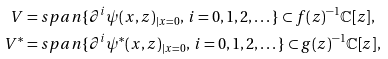Convert formula to latex. <formula><loc_0><loc_0><loc_500><loc_500>V & = s p a n \{ \partial ^ { i } \psi ( x , z ) _ { | x = 0 } , \, i = 0 , 1 , 2 , \dots \} \subset f ( z ) ^ { - 1 } \mathbb { C } [ z ] , \\ V ^ { * } & = s p a n \{ \partial ^ { i } \psi ^ { * } ( x , z ) _ { | x = 0 } , \, i = 0 , 1 , 2 , \dots \} \subset g ( z ) ^ { - 1 } \mathbb { C } [ z ] ,</formula> 